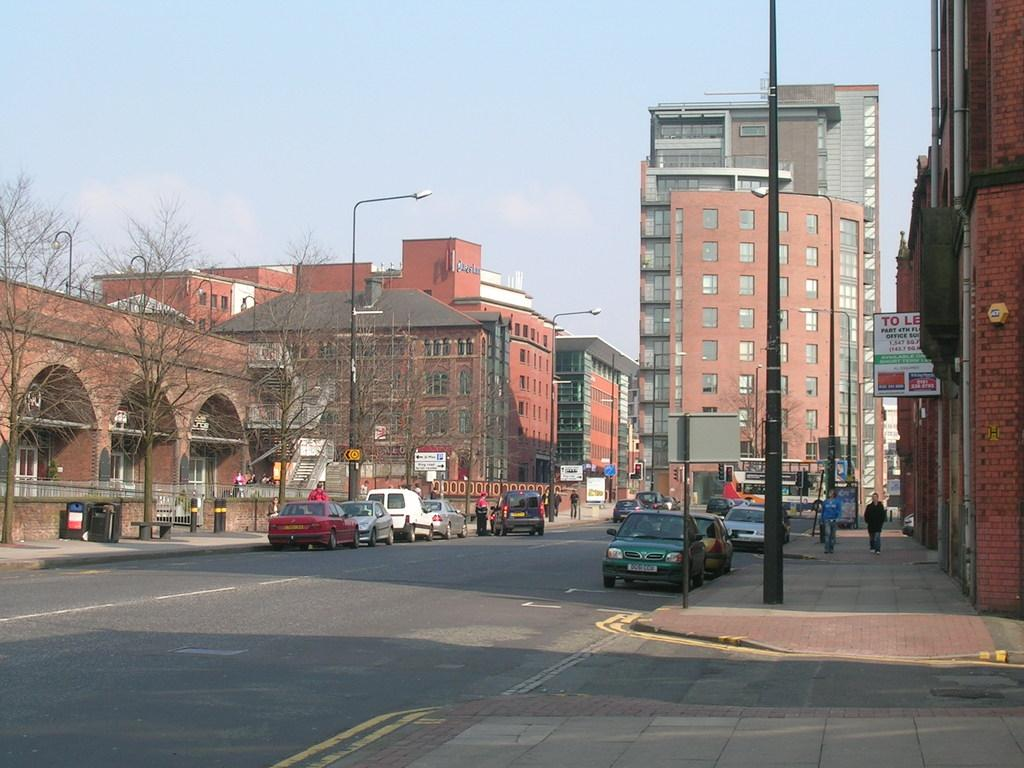What types of structures can be seen in the image? There are buildings in the image. What natural elements are present in the image? There are trees in the image. What man-made objects can be seen in the image? There are poles, boards, and lights in the image. Who or what else is present in the image? There are people and vehicles in the image. What can be seen in the background of the image? The sky is visible in the background of the image. What type of sail can be seen on the vehicle in the image? There are no sails present in the image, as it features vehicles without any sail-like structures. What offer is being made by the buildings in the image? The buildings in the image are not making any offers; they are stationary structures. 